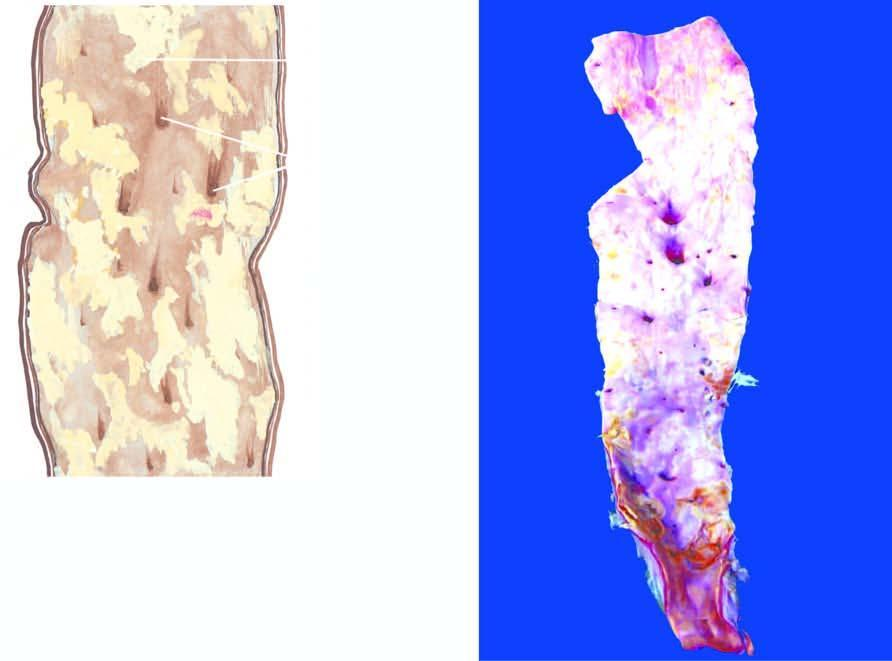what shows a variety of atheromatous lesions?
Answer the question using a single word or phrase. The opened up inner surface of the abdominal aorta 